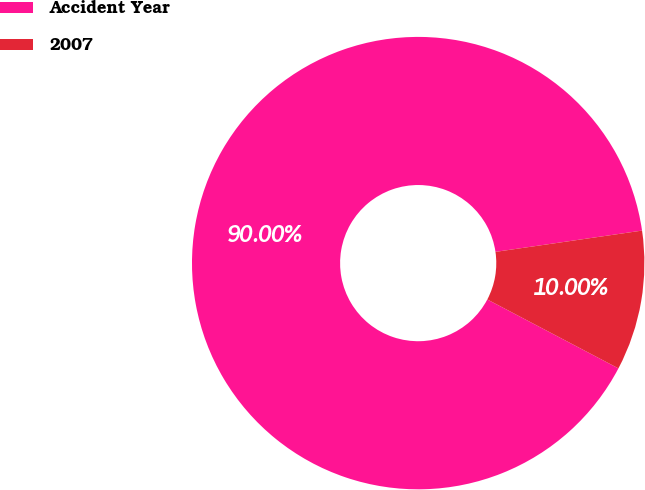<chart> <loc_0><loc_0><loc_500><loc_500><pie_chart><fcel>Accident Year<fcel>2007<nl><fcel>90.0%<fcel>10.0%<nl></chart> 